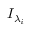<formula> <loc_0><loc_0><loc_500><loc_500>{ { I } _ { { { \lambda } _ { i } } } }</formula> 